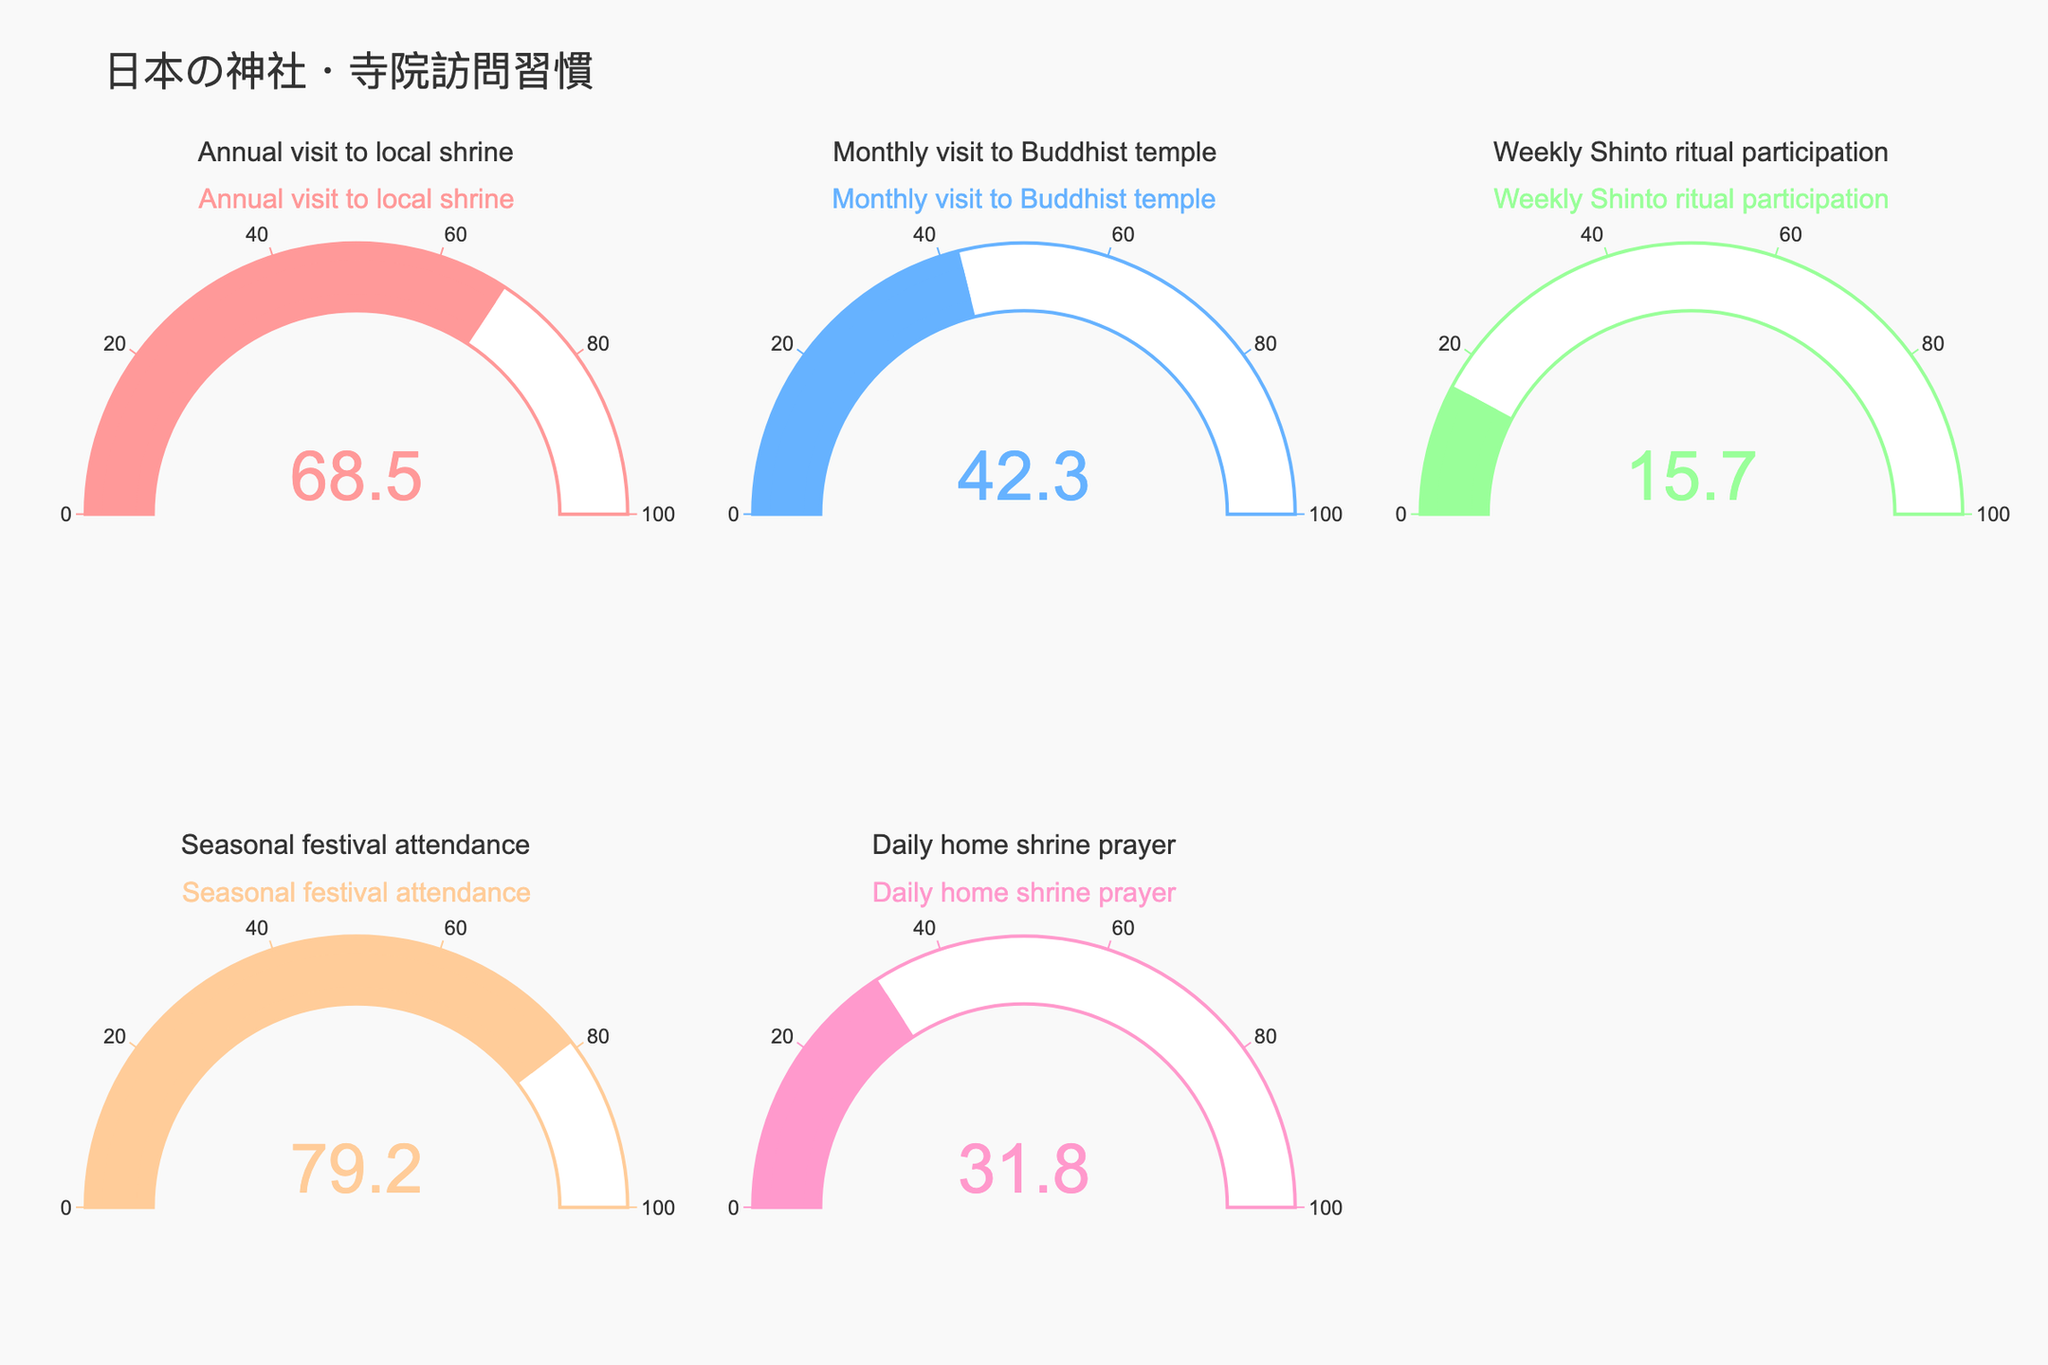What's the title of the chart? The title of the chart is found at the top of the figure. It reads "日本の神社・寺院訪問習慣," which translates to "Visitation Habits to Shrines and Temples in Japan."
Answer: 日本の神社・寺院訪問習慣 Which ritual has the highest percentage of regular participation? By examining the gauge chart, the highest value displayed is 79.2%, which corresponds to "Seasonal festival attendance."
Answer: Seasonal festival attendance What is the percentage of the population that participates in weekly Shinto rituals? Looking at the gauge chart, the gauge representing "Weekly Shinto ritual participation" shows a value of 15.7%.
Answer: 15.7% How many categories are represented in the chart? The chart is divided into individual gauges per category. Counting the titles of each gauge, there are five categories.
Answer: 5 Compare the percentage of the population that visits Buddhist temples monthly to those who pray daily at home shrines. Which is higher and by how much? "Monthly visit to Buddhist temple" shows 42.3%, and "Daily home shrine prayer" shows 31.8%. The difference is 42.3% - 31.8% = 10.5%.
Answer: Monthly visit to Buddhist temple is higher by 10.5% What is the average percentage of the population participating in all the rituals shown? Sum all percentages: 68.5 + 42.3 + 15.7 + 79.2 + 31.8 = 237.5. There are 5 categories, so the average is 237.5 / 5 = 47.5%.
Answer: 47.5% Which two categories have the closest percentages? Comparing all percentages: 68.5%, 42.3%, 15.7%, 79.2%, and 31.8%. The closest are "Monthly visit to Buddhist temple" at 42.3% and "Daily home shrine prayer" at 31.8%, with a difference of 10.5%.
Answer: Monthly visit to Buddhist temple and Daily home shrine prayer What is the combined percentage of participants in annual and seasonal activities? Annual visit to local shrine is 68.5% and Seasonal festival attendance is 79.2%. Total combined percentage is 68.5% + 79.2% = 147.7%.
Answer: 147.7% Are any categories below 20% participation? If yes, which ones? From the chart, the category "Weekly Shinto ritual participation" has a percentage of 15.7%, which is below 20%.
Answer: Weekly Shinto ritual participation 